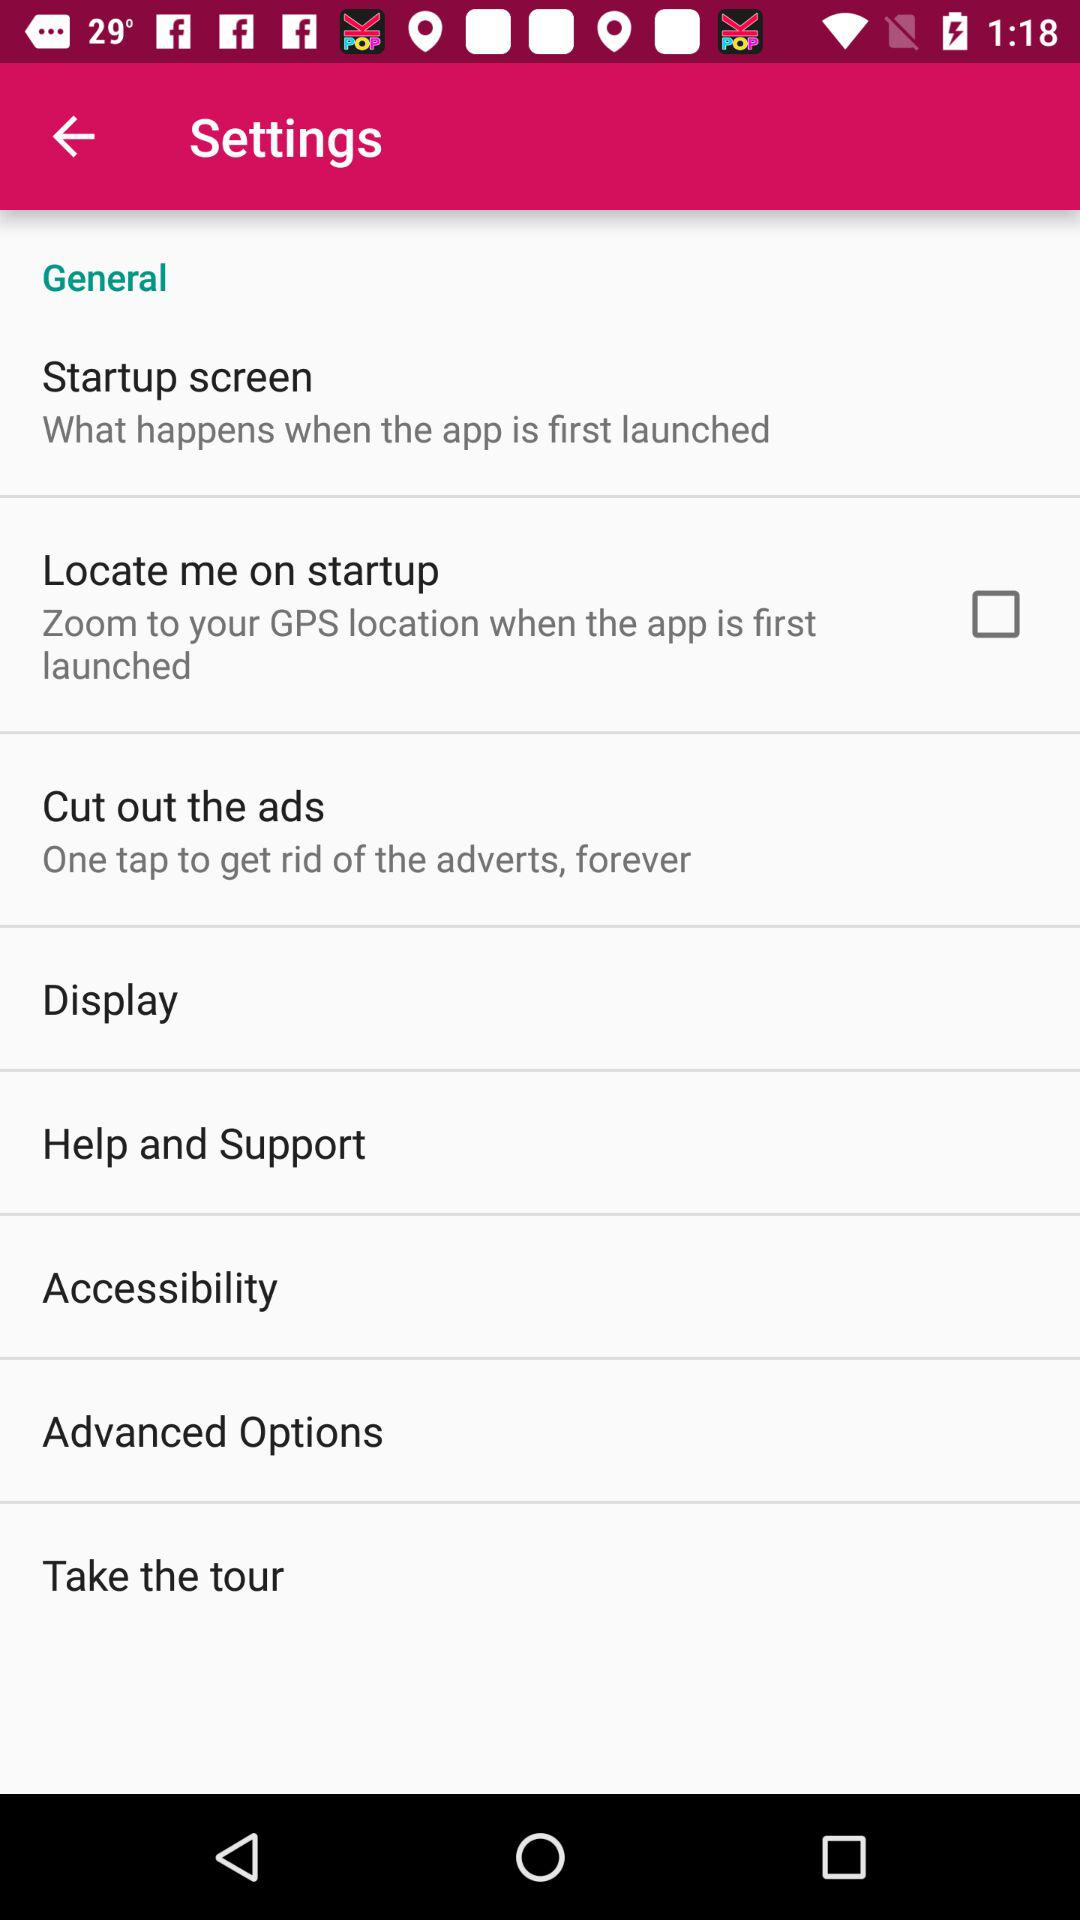What is the status of "Locate me on startup"? The status of "Locate me on startup" is "off". 